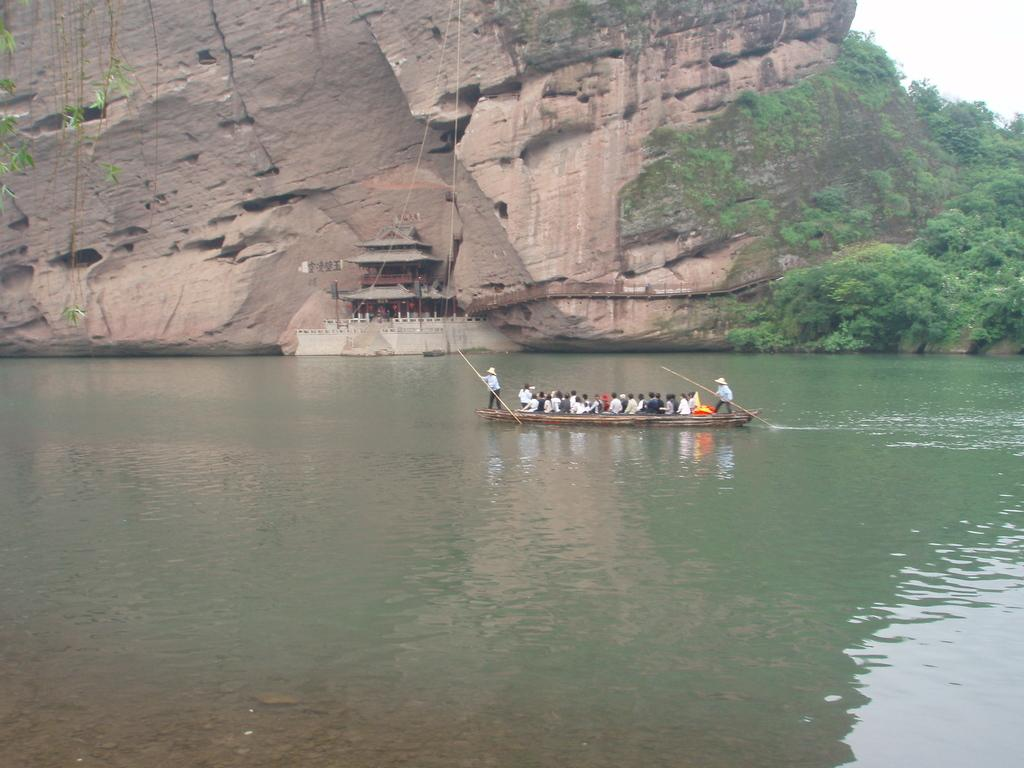What is the main subject of the image? The main subject of the image is persons in a boat. Where is the boat located in the image? The boat is sailing on a river in the center of the image. What can be seen in the background of the image? There is a hill, trees, a temple, and the sky visible in the background of the image. How many pages are visible in the image? There are no pages present in the image; it features a boat sailing on a river with a background of hills, trees, a temple, and the sky. What type of goose can be seen swimming alongside the boat in the image? There is no goose present in the image; it only features a boat sailing on a river with a background of hills, trees, a temple, and the sky. 